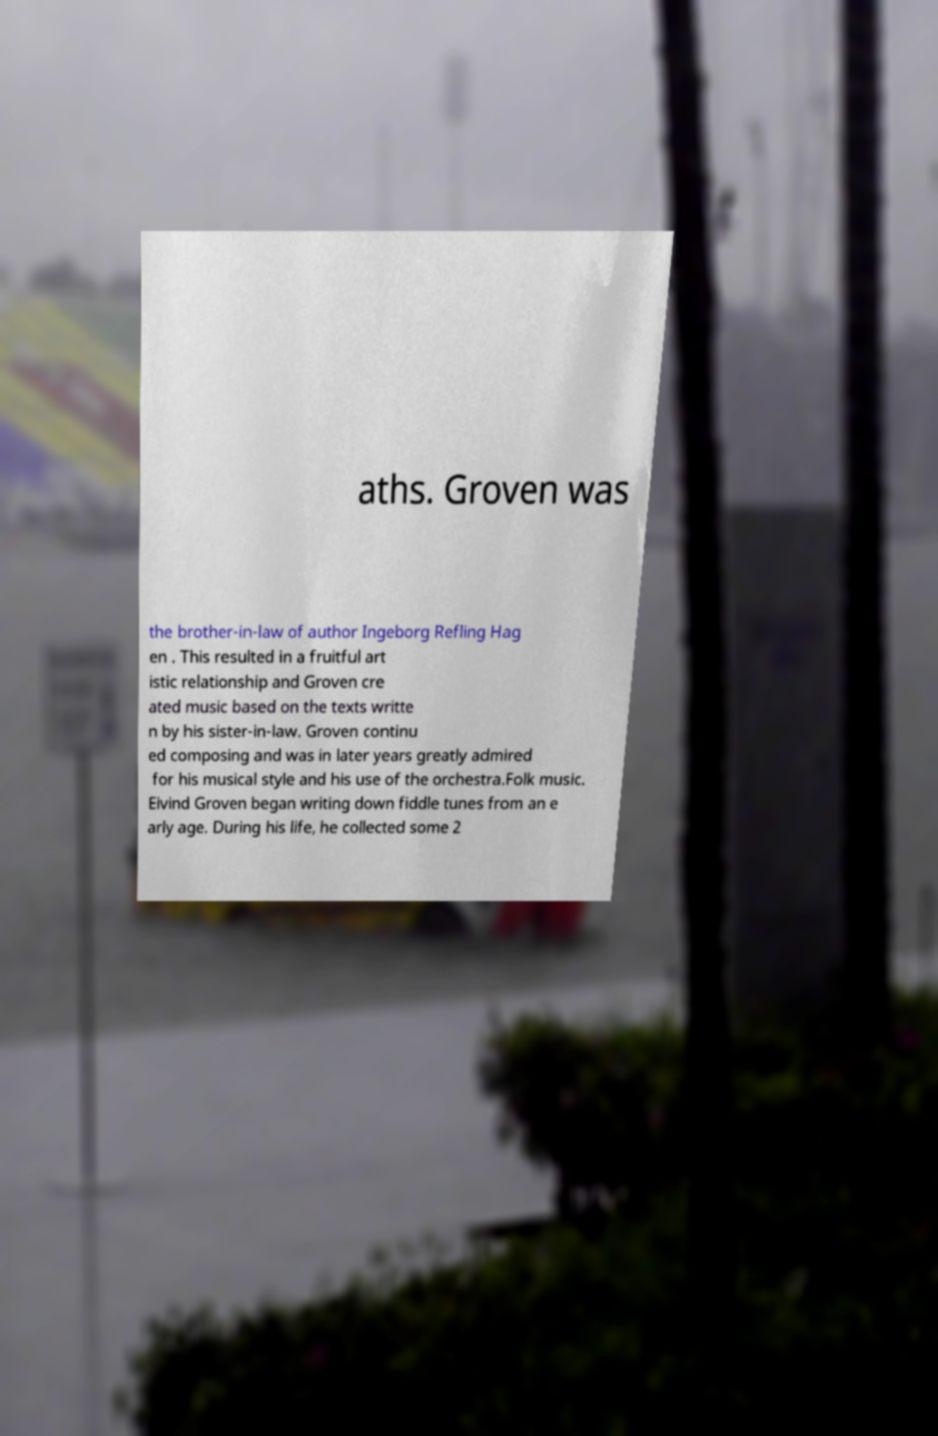Could you extract and type out the text from this image? aths. Groven was the brother-in-law of author Ingeborg Refling Hag en . This resulted in a fruitful art istic relationship and Groven cre ated music based on the texts writte n by his sister-in-law. Groven continu ed composing and was in later years greatly admired for his musical style and his use of the orchestra.Folk music. Eivind Groven began writing down fiddle tunes from an e arly age. During his life, he collected some 2 